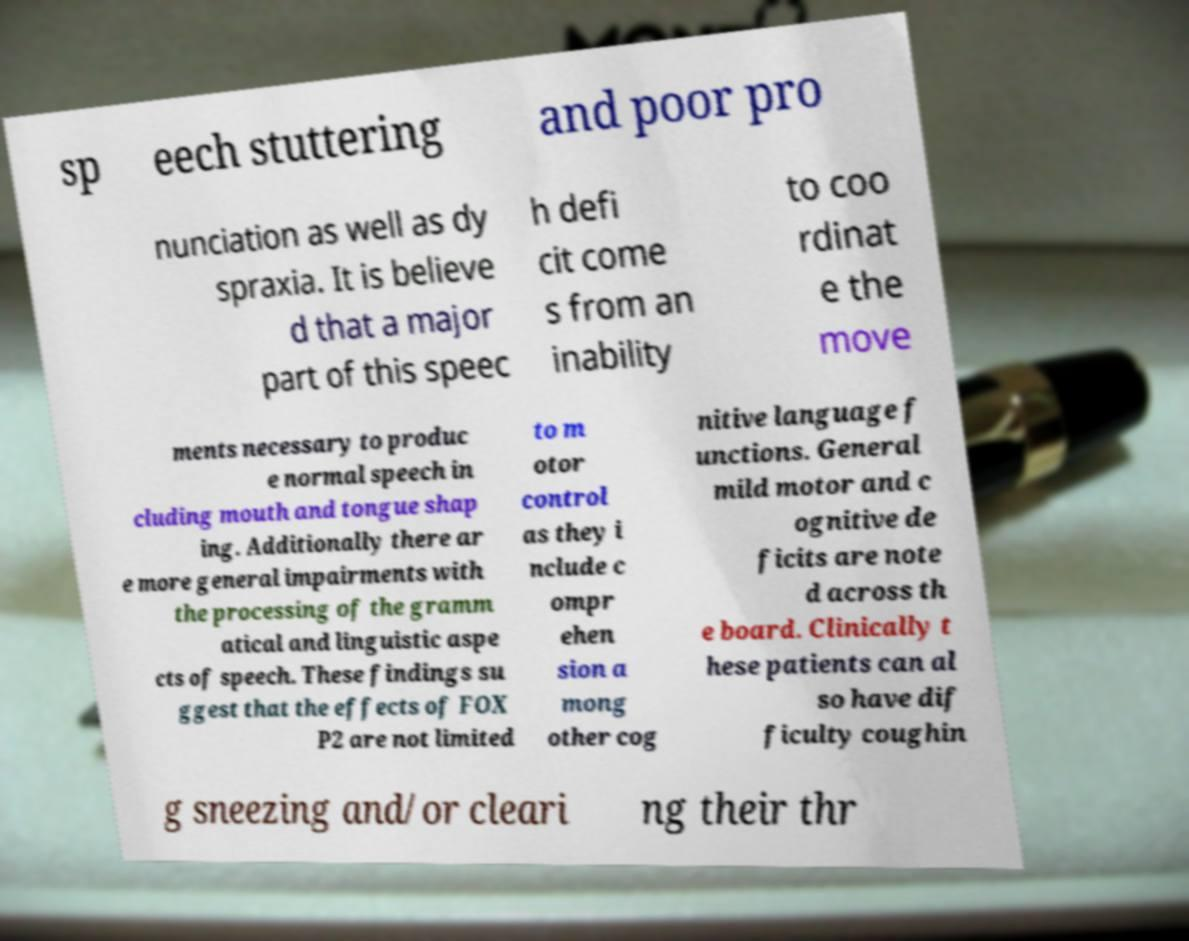What messages or text are displayed in this image? I need them in a readable, typed format. sp eech stuttering and poor pro nunciation as well as dy spraxia. It is believe d that a major part of this speec h defi cit come s from an inability to coo rdinat e the move ments necessary to produc e normal speech in cluding mouth and tongue shap ing. Additionally there ar e more general impairments with the processing of the gramm atical and linguistic aspe cts of speech. These findings su ggest that the effects of FOX P2 are not limited to m otor control as they i nclude c ompr ehen sion a mong other cog nitive language f unctions. General mild motor and c ognitive de ficits are note d across th e board. Clinically t hese patients can al so have dif ficulty coughin g sneezing and/or cleari ng their thr 